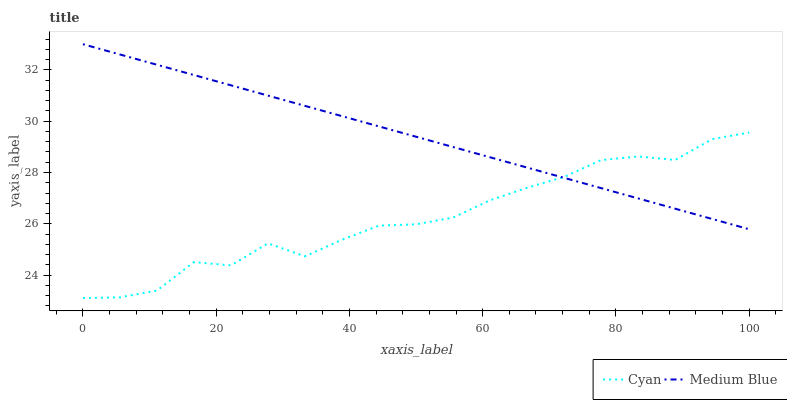Does Medium Blue have the minimum area under the curve?
Answer yes or no. No. Is Medium Blue the roughest?
Answer yes or no. No. Does Medium Blue have the lowest value?
Answer yes or no. No. 